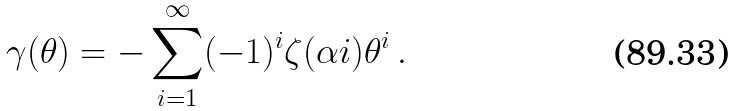<formula> <loc_0><loc_0><loc_500><loc_500>\gamma ( \theta ) = - \sum _ { i = 1 } ^ { \infty } ( - 1 ) ^ { i } \zeta ( \alpha i ) \theta ^ { i } \, .</formula> 